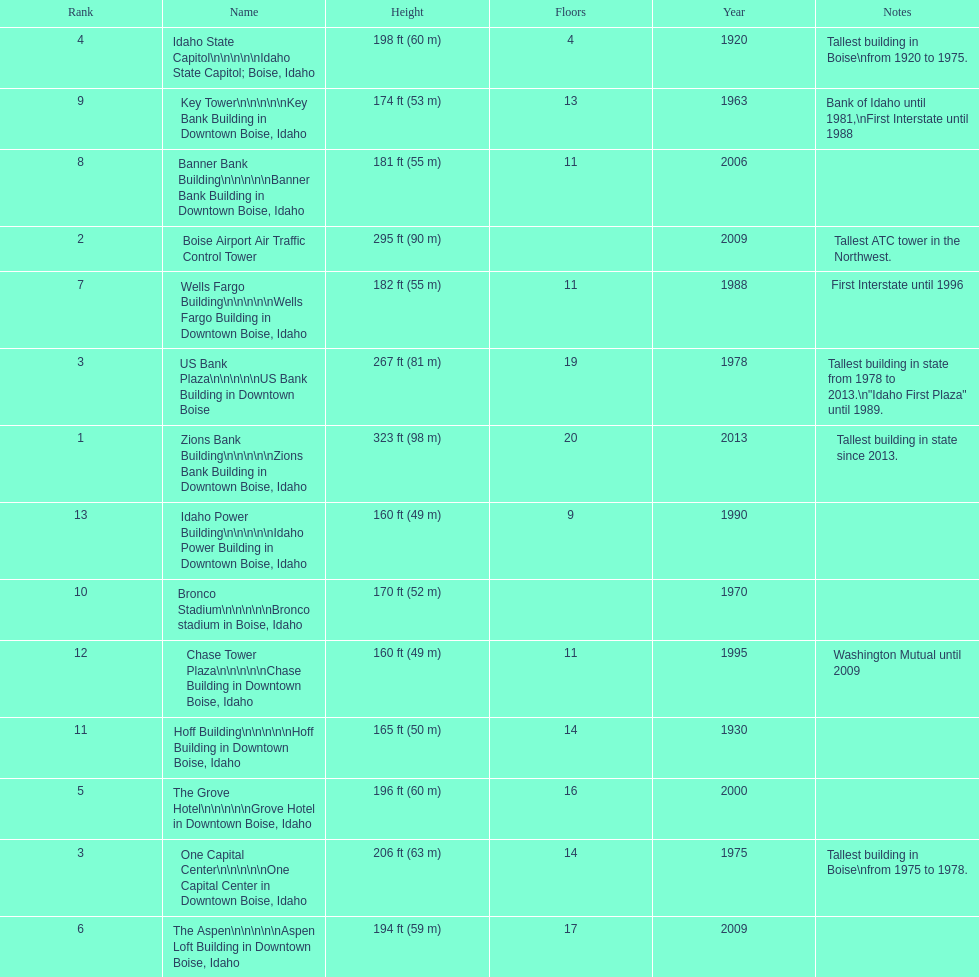What is the name of the last building on this chart? Idaho Power Building. 